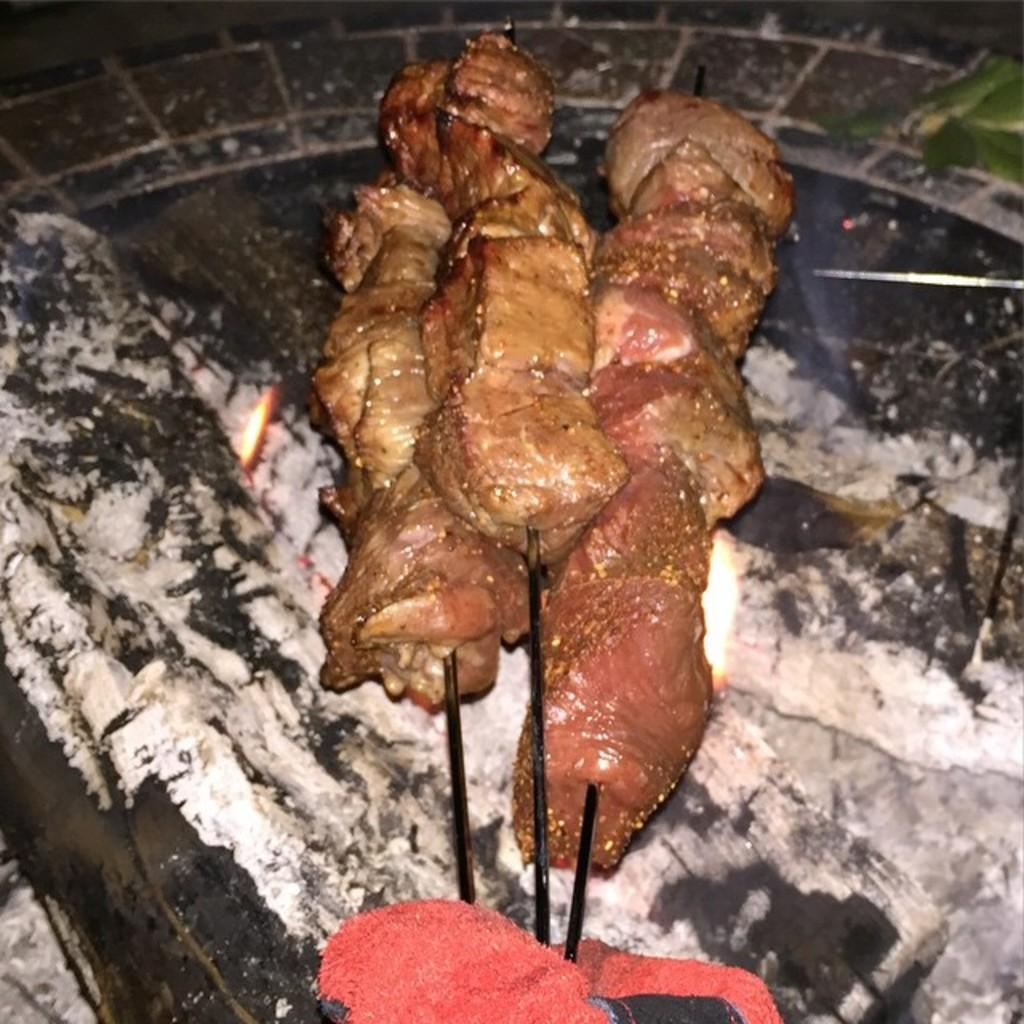What is the main subject of the image? There is a food item in the image. What advice does the food item give to the horses in the image? There are no horses present in the image, and the food item cannot give advice as it is an inanimate object. 